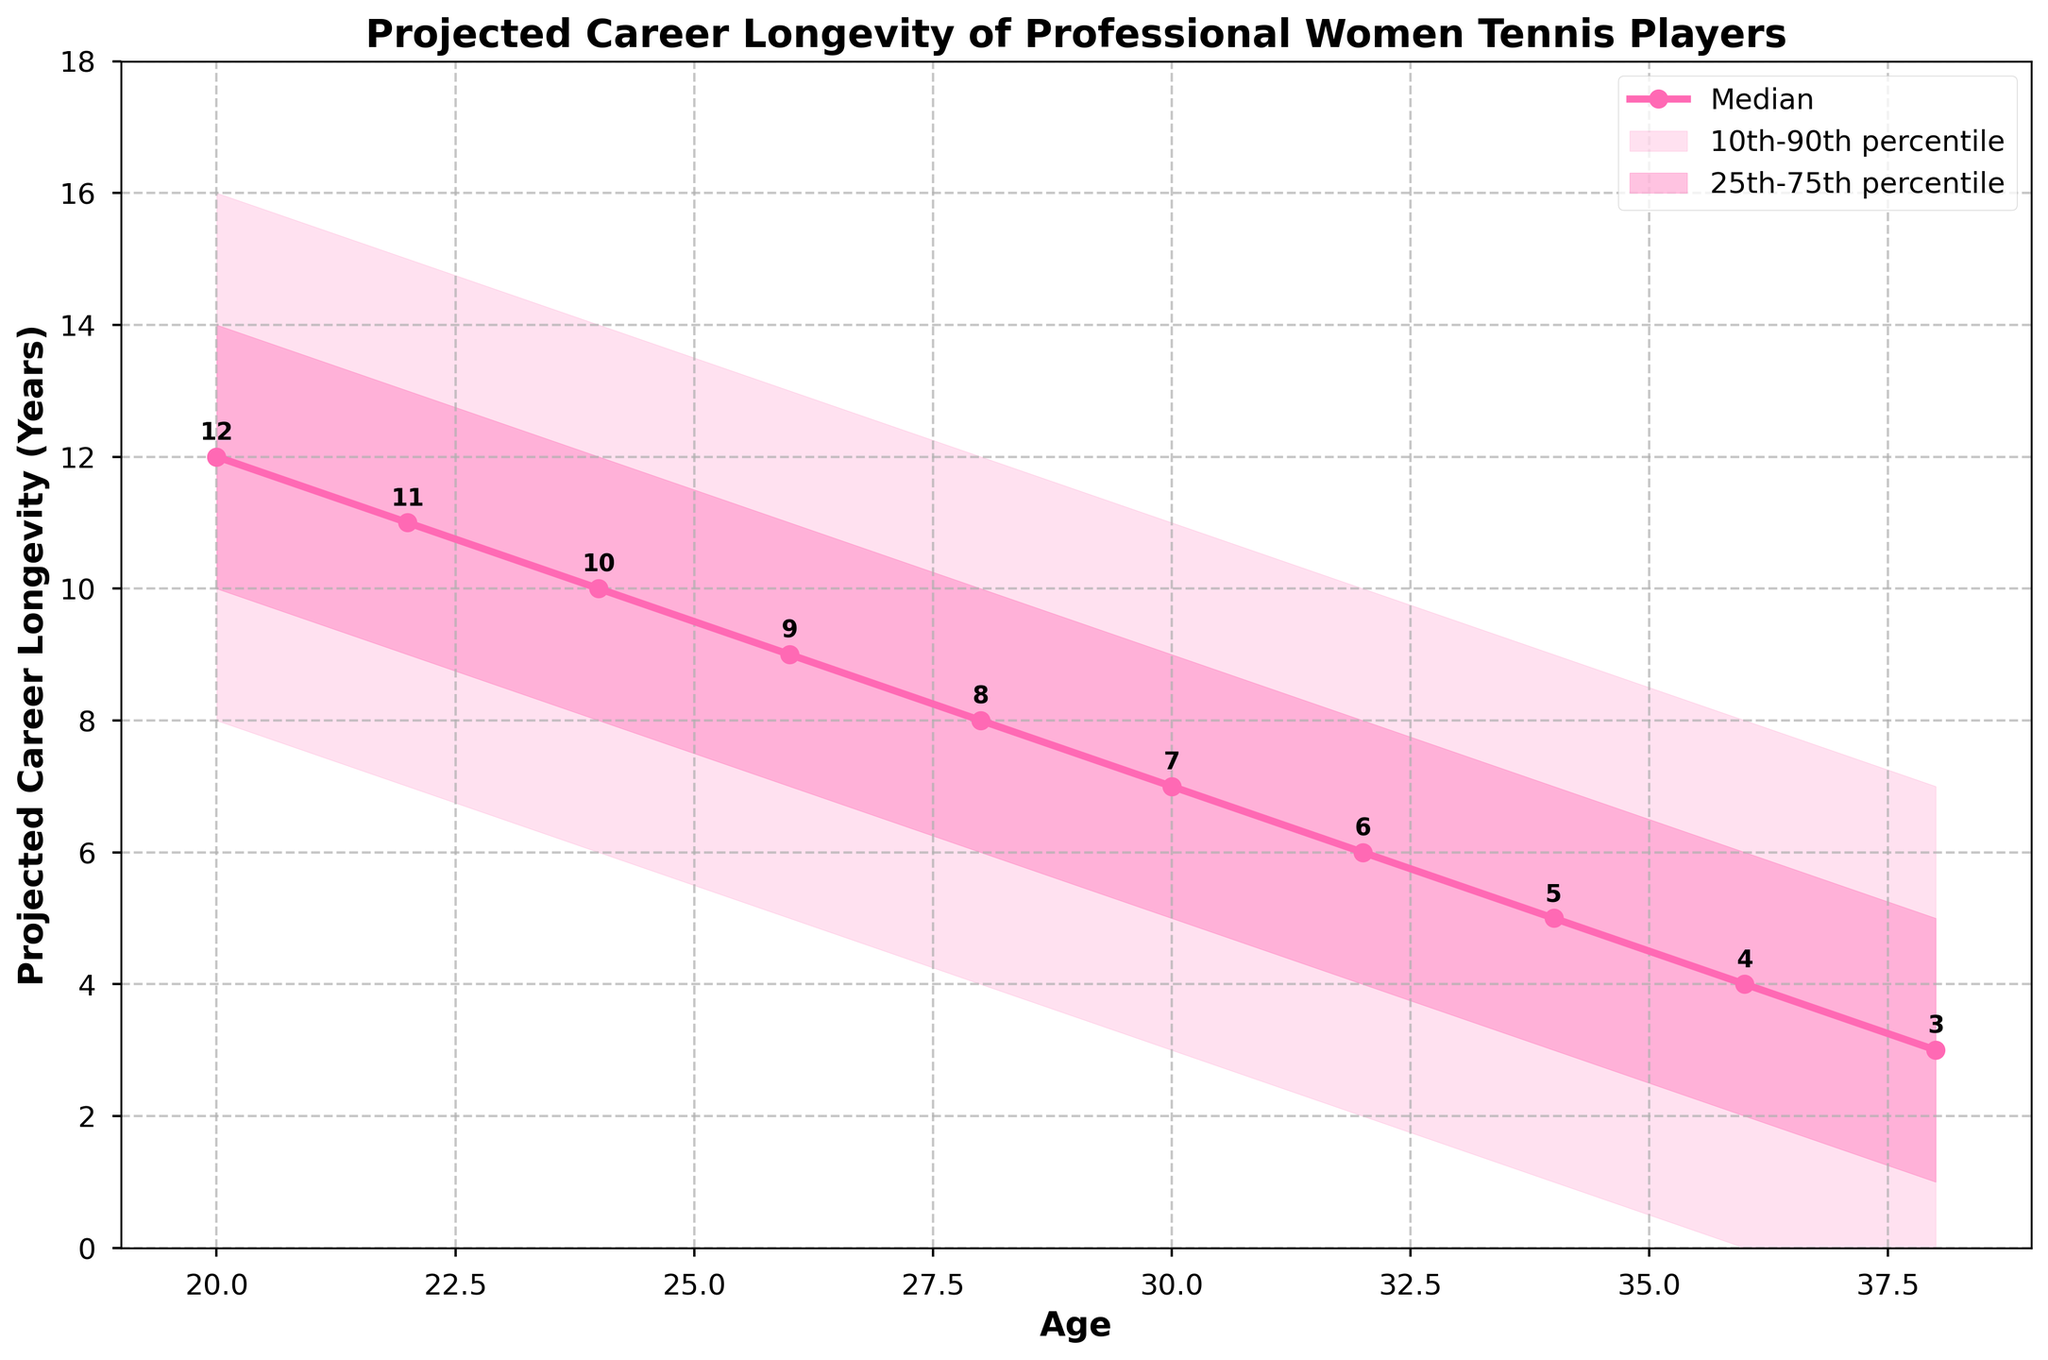What's the median projected career longevity of professional women tennis players at age 24? To find the median projected career longevity at age 24, look at the data point where the Age is 24 on the x-axis, and then refer to the Median Longevity value on the y-axis.
Answer: 10 What is the range of projected career longevity (10th-90th percentile) for players aged 28? For age 28, check the Lower_10th and Upper_90th values. The Lower_10th is 4 years and the Upper_90th is 12 years. The range is from 4 to 12 years.
Answer: 4 to 12 years At what age does the median projected career longevity fall below 7 years? Observe the median longevity line and locate the age where the value first drops below 7 years. This occurs between ages 30 and 32.
Answer: 30 Which percentile range is narrower for players aged 36: 10th-90th or 25th-75th? For age 36, the 10th-90th range is from 0 to 8 (8 years) and the 25th-75th range is from 2 to 6 (4 years). The 25th-75th range is narrower.
Answer: 25th-75th Compare the median projected career longevity of players aged 22 and 28. Which is higher? Check the median longevity for ages 22 and 28. For age 22, it is 11 years, and for age 28, it is 8 years. 11 years is higher.
Answer: 22 What can you infer about the trend of median projected career longevity as players age? Analyze the median line trend: as age increases from 20 to 38, the median projected longevity decreases consistently.
Answer: Decreases with age How much longer is the median projected career longevity for a 20-year-old compared to a 38-year-old? Compare the median values: 20-year-old median is 12 years, 38-year-old median is 3 years. The difference is 12 - 3 = 9 years.
Answer: 9 years Which age shows the widest spread in projected career longevity (10th-90th percentile)? Calculate the spread for each age group: Age 20 has the widest spread with Upper_90th = 16 and Lower_10th = 8, giving a spread of 8 years.
Answer: 20 For which age is the 25th percentile projected career longevity equal to 4 years? Look at the 25th percentile values: Age 32 is the closest, where the 25th percentile is 4 years.
Answer: 32 